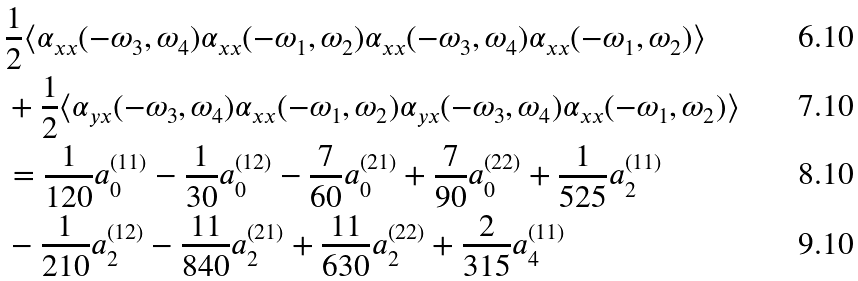<formula> <loc_0><loc_0><loc_500><loc_500>& \frac { 1 } { 2 } \langle \alpha _ { x x } ( - \omega _ { 3 } , \omega _ { 4 } ) \alpha _ { x x } ( - \omega _ { 1 } , \omega _ { 2 } ) \alpha _ { x x } ( - \omega _ { 3 } , \omega _ { 4 } ) \alpha _ { x x } ( - \omega _ { 1 } , \omega _ { 2 } ) \rangle \\ & + \frac { 1 } { 2 } \langle \alpha _ { y x } ( - \omega _ { 3 } , \omega _ { 4 } ) \alpha _ { x x } ( - \omega _ { 1 } , \omega _ { 2 } ) \alpha _ { y x } ( - \omega _ { 3 } , \omega _ { 4 } ) \alpha _ { x x } ( - \omega _ { 1 } , \omega _ { 2 } ) \rangle \\ & = \frac { 1 } { 1 2 0 } a _ { 0 } ^ { ( 1 1 ) } - \frac { 1 } { 3 0 } a _ { 0 } ^ { ( 1 2 ) } - \frac { 7 } { 6 0 } a _ { 0 } ^ { ( 2 1 ) } + \frac { 7 } { 9 0 } a _ { 0 } ^ { ( 2 2 ) } + \frac { 1 } { 5 2 5 } a _ { 2 } ^ { ( 1 1 ) } \\ & - \frac { 1 } { 2 1 0 } a _ { 2 } ^ { ( 1 2 ) } - \frac { 1 1 } { 8 4 0 } a _ { 2 } ^ { ( 2 1 ) } + \frac { 1 1 } { 6 3 0 } a _ { 2 } ^ { ( 2 2 ) } + \frac { 2 } { 3 1 5 } a _ { 4 } ^ { ( 1 1 ) }</formula> 